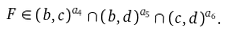<formula> <loc_0><loc_0><loc_500><loc_500>F \in ( b , c ) ^ { a _ { 4 } } \cap ( b , d ) ^ { a _ { 5 } } \cap ( c , d ) ^ { a _ { 6 } } .</formula> 